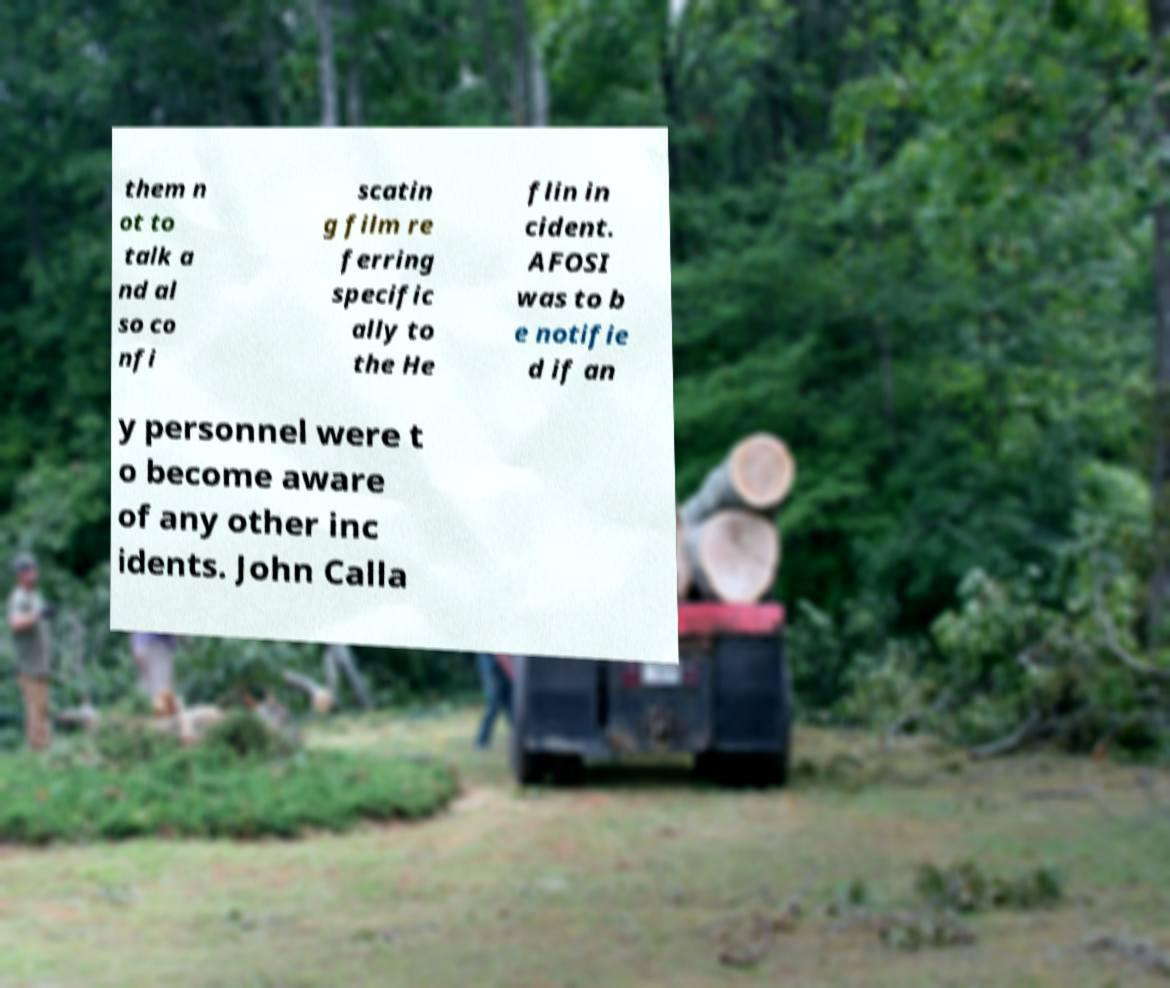There's text embedded in this image that I need extracted. Can you transcribe it verbatim? them n ot to talk a nd al so co nfi scatin g film re ferring specific ally to the He flin in cident. AFOSI was to b e notifie d if an y personnel were t o become aware of any other inc idents. John Calla 